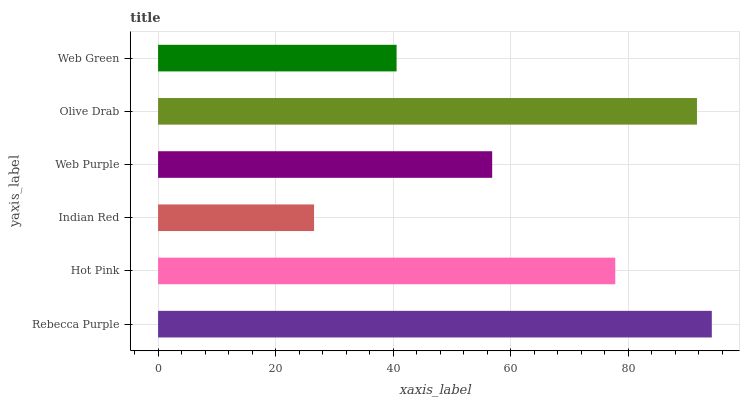Is Indian Red the minimum?
Answer yes or no. Yes. Is Rebecca Purple the maximum?
Answer yes or no. Yes. Is Hot Pink the minimum?
Answer yes or no. No. Is Hot Pink the maximum?
Answer yes or no. No. Is Rebecca Purple greater than Hot Pink?
Answer yes or no. Yes. Is Hot Pink less than Rebecca Purple?
Answer yes or no. Yes. Is Hot Pink greater than Rebecca Purple?
Answer yes or no. No. Is Rebecca Purple less than Hot Pink?
Answer yes or no. No. Is Hot Pink the high median?
Answer yes or no. Yes. Is Web Purple the low median?
Answer yes or no. Yes. Is Rebecca Purple the high median?
Answer yes or no. No. Is Rebecca Purple the low median?
Answer yes or no. No. 